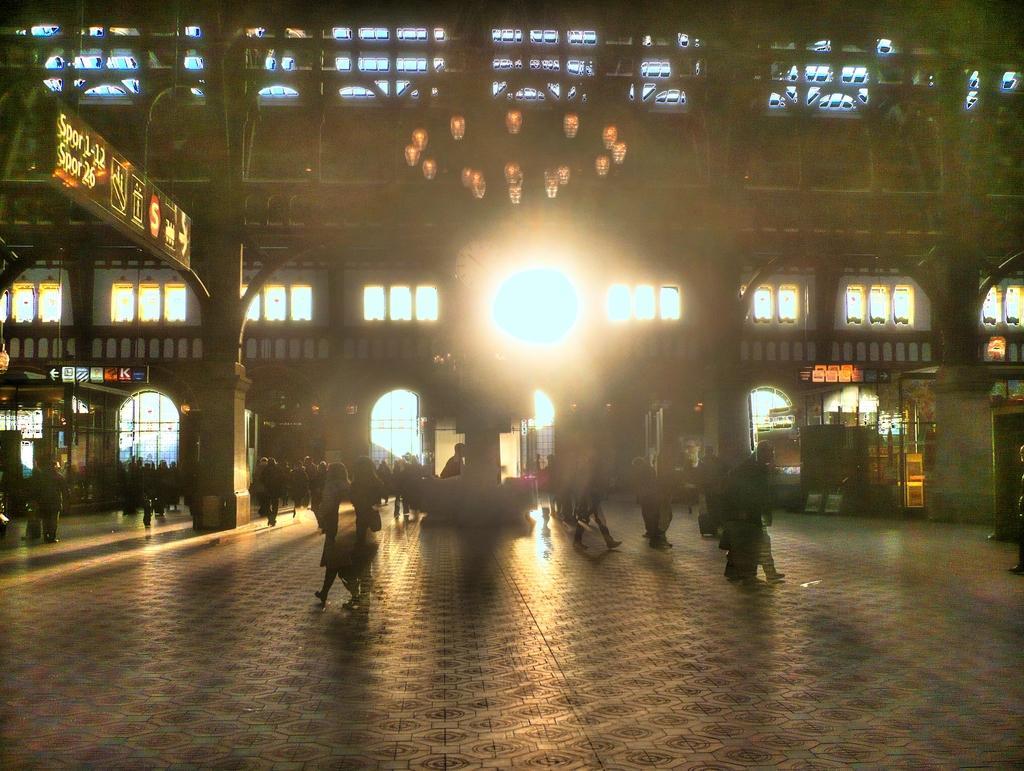In one or two sentences, can you explain what this image depicts? Here few persons are walking on this, it is a building, in the middle there is a light. 